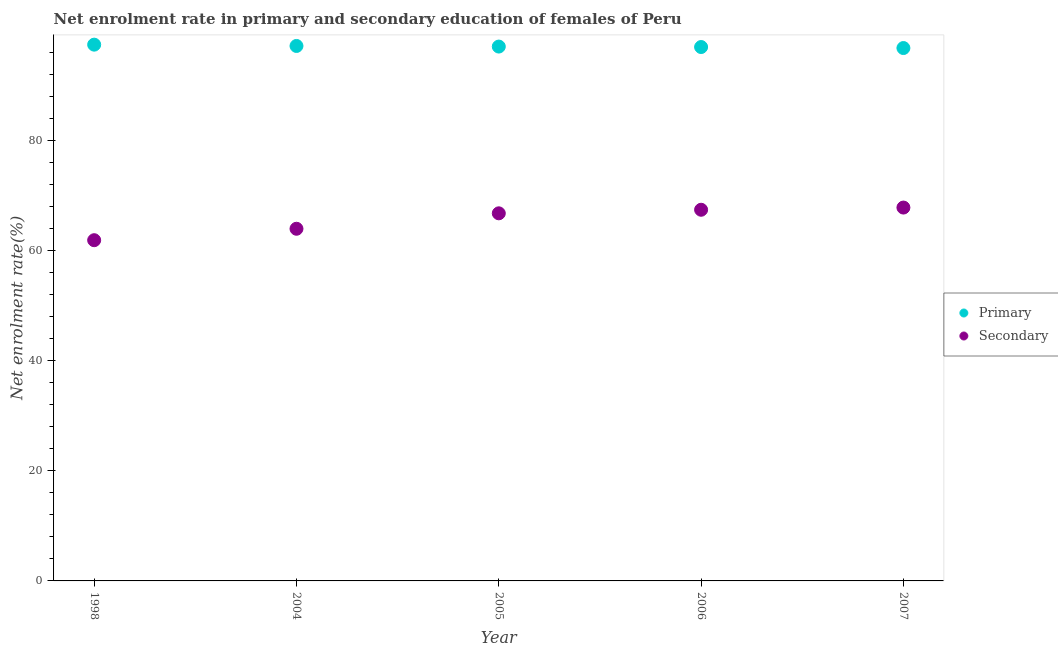What is the enrollment rate in primary education in 1998?
Ensure brevity in your answer.  97.48. Across all years, what is the maximum enrollment rate in secondary education?
Provide a succinct answer. 67.87. Across all years, what is the minimum enrollment rate in secondary education?
Provide a short and direct response. 61.94. In which year was the enrollment rate in primary education maximum?
Your answer should be compact. 1998. In which year was the enrollment rate in secondary education minimum?
Your answer should be very brief. 1998. What is the total enrollment rate in secondary education in the graph?
Ensure brevity in your answer.  328.12. What is the difference between the enrollment rate in primary education in 2005 and that in 2006?
Your response must be concise. 0.08. What is the difference between the enrollment rate in secondary education in 2006 and the enrollment rate in primary education in 2005?
Make the answer very short. -29.66. What is the average enrollment rate in primary education per year?
Make the answer very short. 97.16. In the year 2005, what is the difference between the enrollment rate in primary education and enrollment rate in secondary education?
Provide a succinct answer. 30.31. In how many years, is the enrollment rate in secondary education greater than 24 %?
Make the answer very short. 5. What is the ratio of the enrollment rate in primary education in 2005 to that in 2006?
Offer a very short reply. 1. Is the enrollment rate in primary education in 2006 less than that in 2007?
Offer a very short reply. No. Is the difference between the enrollment rate in secondary education in 1998 and 2004 greater than the difference between the enrollment rate in primary education in 1998 and 2004?
Provide a succinct answer. No. What is the difference between the highest and the second highest enrollment rate in secondary education?
Provide a short and direct response. 0.4. What is the difference between the highest and the lowest enrollment rate in primary education?
Ensure brevity in your answer.  0.62. Is the enrollment rate in primary education strictly greater than the enrollment rate in secondary education over the years?
Offer a terse response. Yes. Is the enrollment rate in primary education strictly less than the enrollment rate in secondary education over the years?
Provide a succinct answer. No. How many years are there in the graph?
Your answer should be very brief. 5. Are the values on the major ticks of Y-axis written in scientific E-notation?
Ensure brevity in your answer.  No. Does the graph contain grids?
Keep it short and to the point. No. What is the title of the graph?
Provide a succinct answer. Net enrolment rate in primary and secondary education of females of Peru. Does "Under-5(female)" appear as one of the legend labels in the graph?
Make the answer very short. No. What is the label or title of the Y-axis?
Give a very brief answer. Net enrolment rate(%). What is the Net enrolment rate(%) of Primary in 1998?
Your answer should be compact. 97.48. What is the Net enrolment rate(%) in Secondary in 1998?
Your answer should be very brief. 61.94. What is the Net enrolment rate(%) in Primary in 2004?
Your response must be concise. 97.25. What is the Net enrolment rate(%) of Secondary in 2004?
Your response must be concise. 64.02. What is the Net enrolment rate(%) in Primary in 2005?
Your answer should be compact. 97.14. What is the Net enrolment rate(%) in Secondary in 2005?
Make the answer very short. 66.82. What is the Net enrolment rate(%) in Primary in 2006?
Your response must be concise. 97.05. What is the Net enrolment rate(%) of Secondary in 2006?
Your answer should be compact. 67.47. What is the Net enrolment rate(%) in Primary in 2007?
Offer a very short reply. 96.87. What is the Net enrolment rate(%) of Secondary in 2007?
Your answer should be compact. 67.87. Across all years, what is the maximum Net enrolment rate(%) in Primary?
Provide a succinct answer. 97.48. Across all years, what is the maximum Net enrolment rate(%) in Secondary?
Give a very brief answer. 67.87. Across all years, what is the minimum Net enrolment rate(%) of Primary?
Keep it short and to the point. 96.87. Across all years, what is the minimum Net enrolment rate(%) in Secondary?
Your answer should be very brief. 61.94. What is the total Net enrolment rate(%) in Primary in the graph?
Your response must be concise. 485.79. What is the total Net enrolment rate(%) in Secondary in the graph?
Make the answer very short. 328.12. What is the difference between the Net enrolment rate(%) of Primary in 1998 and that in 2004?
Your response must be concise. 0.24. What is the difference between the Net enrolment rate(%) in Secondary in 1998 and that in 2004?
Make the answer very short. -2.08. What is the difference between the Net enrolment rate(%) in Primary in 1998 and that in 2005?
Your answer should be compact. 0.35. What is the difference between the Net enrolment rate(%) in Secondary in 1998 and that in 2005?
Make the answer very short. -4.89. What is the difference between the Net enrolment rate(%) of Primary in 1998 and that in 2006?
Offer a very short reply. 0.43. What is the difference between the Net enrolment rate(%) of Secondary in 1998 and that in 2006?
Offer a terse response. -5.54. What is the difference between the Net enrolment rate(%) in Primary in 1998 and that in 2007?
Offer a terse response. 0.62. What is the difference between the Net enrolment rate(%) of Secondary in 1998 and that in 2007?
Provide a succinct answer. -5.93. What is the difference between the Net enrolment rate(%) in Primary in 2004 and that in 2005?
Keep it short and to the point. 0.11. What is the difference between the Net enrolment rate(%) in Secondary in 2004 and that in 2005?
Make the answer very short. -2.81. What is the difference between the Net enrolment rate(%) in Primary in 2004 and that in 2006?
Your response must be concise. 0.19. What is the difference between the Net enrolment rate(%) of Secondary in 2004 and that in 2006?
Provide a short and direct response. -3.46. What is the difference between the Net enrolment rate(%) of Primary in 2004 and that in 2007?
Offer a very short reply. 0.38. What is the difference between the Net enrolment rate(%) of Secondary in 2004 and that in 2007?
Provide a short and direct response. -3.85. What is the difference between the Net enrolment rate(%) in Primary in 2005 and that in 2006?
Your answer should be compact. 0.08. What is the difference between the Net enrolment rate(%) of Secondary in 2005 and that in 2006?
Offer a terse response. -0.65. What is the difference between the Net enrolment rate(%) of Primary in 2005 and that in 2007?
Offer a terse response. 0.27. What is the difference between the Net enrolment rate(%) of Secondary in 2005 and that in 2007?
Offer a very short reply. -1.05. What is the difference between the Net enrolment rate(%) of Primary in 2006 and that in 2007?
Your response must be concise. 0.18. What is the difference between the Net enrolment rate(%) in Secondary in 2006 and that in 2007?
Your answer should be very brief. -0.4. What is the difference between the Net enrolment rate(%) of Primary in 1998 and the Net enrolment rate(%) of Secondary in 2004?
Keep it short and to the point. 33.47. What is the difference between the Net enrolment rate(%) of Primary in 1998 and the Net enrolment rate(%) of Secondary in 2005?
Provide a short and direct response. 30.66. What is the difference between the Net enrolment rate(%) in Primary in 1998 and the Net enrolment rate(%) in Secondary in 2006?
Provide a succinct answer. 30.01. What is the difference between the Net enrolment rate(%) of Primary in 1998 and the Net enrolment rate(%) of Secondary in 2007?
Give a very brief answer. 29.61. What is the difference between the Net enrolment rate(%) in Primary in 2004 and the Net enrolment rate(%) in Secondary in 2005?
Give a very brief answer. 30.42. What is the difference between the Net enrolment rate(%) in Primary in 2004 and the Net enrolment rate(%) in Secondary in 2006?
Your response must be concise. 29.77. What is the difference between the Net enrolment rate(%) in Primary in 2004 and the Net enrolment rate(%) in Secondary in 2007?
Keep it short and to the point. 29.38. What is the difference between the Net enrolment rate(%) of Primary in 2005 and the Net enrolment rate(%) of Secondary in 2006?
Give a very brief answer. 29.66. What is the difference between the Net enrolment rate(%) of Primary in 2005 and the Net enrolment rate(%) of Secondary in 2007?
Make the answer very short. 29.27. What is the difference between the Net enrolment rate(%) in Primary in 2006 and the Net enrolment rate(%) in Secondary in 2007?
Provide a succinct answer. 29.18. What is the average Net enrolment rate(%) of Primary per year?
Keep it short and to the point. 97.16. What is the average Net enrolment rate(%) in Secondary per year?
Your answer should be very brief. 65.62. In the year 1998, what is the difference between the Net enrolment rate(%) in Primary and Net enrolment rate(%) in Secondary?
Offer a terse response. 35.55. In the year 2004, what is the difference between the Net enrolment rate(%) of Primary and Net enrolment rate(%) of Secondary?
Provide a short and direct response. 33.23. In the year 2005, what is the difference between the Net enrolment rate(%) of Primary and Net enrolment rate(%) of Secondary?
Your answer should be very brief. 30.31. In the year 2006, what is the difference between the Net enrolment rate(%) in Primary and Net enrolment rate(%) in Secondary?
Offer a terse response. 29.58. In the year 2007, what is the difference between the Net enrolment rate(%) in Primary and Net enrolment rate(%) in Secondary?
Provide a succinct answer. 29. What is the ratio of the Net enrolment rate(%) in Secondary in 1998 to that in 2004?
Provide a short and direct response. 0.97. What is the ratio of the Net enrolment rate(%) of Secondary in 1998 to that in 2005?
Provide a short and direct response. 0.93. What is the ratio of the Net enrolment rate(%) of Primary in 1998 to that in 2006?
Offer a terse response. 1. What is the ratio of the Net enrolment rate(%) in Secondary in 1998 to that in 2006?
Offer a terse response. 0.92. What is the ratio of the Net enrolment rate(%) in Primary in 1998 to that in 2007?
Offer a terse response. 1.01. What is the ratio of the Net enrolment rate(%) in Secondary in 1998 to that in 2007?
Keep it short and to the point. 0.91. What is the ratio of the Net enrolment rate(%) of Secondary in 2004 to that in 2005?
Offer a terse response. 0.96. What is the ratio of the Net enrolment rate(%) of Primary in 2004 to that in 2006?
Provide a short and direct response. 1. What is the ratio of the Net enrolment rate(%) of Secondary in 2004 to that in 2006?
Keep it short and to the point. 0.95. What is the ratio of the Net enrolment rate(%) in Primary in 2004 to that in 2007?
Provide a succinct answer. 1. What is the ratio of the Net enrolment rate(%) in Secondary in 2004 to that in 2007?
Keep it short and to the point. 0.94. What is the ratio of the Net enrolment rate(%) of Primary in 2005 to that in 2006?
Ensure brevity in your answer.  1. What is the ratio of the Net enrolment rate(%) of Secondary in 2005 to that in 2006?
Offer a terse response. 0.99. What is the ratio of the Net enrolment rate(%) in Primary in 2005 to that in 2007?
Provide a succinct answer. 1. What is the ratio of the Net enrolment rate(%) in Secondary in 2005 to that in 2007?
Offer a very short reply. 0.98. What is the ratio of the Net enrolment rate(%) of Primary in 2006 to that in 2007?
Ensure brevity in your answer.  1. What is the ratio of the Net enrolment rate(%) in Secondary in 2006 to that in 2007?
Your answer should be very brief. 0.99. What is the difference between the highest and the second highest Net enrolment rate(%) in Primary?
Your answer should be very brief. 0.24. What is the difference between the highest and the second highest Net enrolment rate(%) of Secondary?
Your answer should be compact. 0.4. What is the difference between the highest and the lowest Net enrolment rate(%) of Primary?
Offer a terse response. 0.62. What is the difference between the highest and the lowest Net enrolment rate(%) in Secondary?
Give a very brief answer. 5.93. 